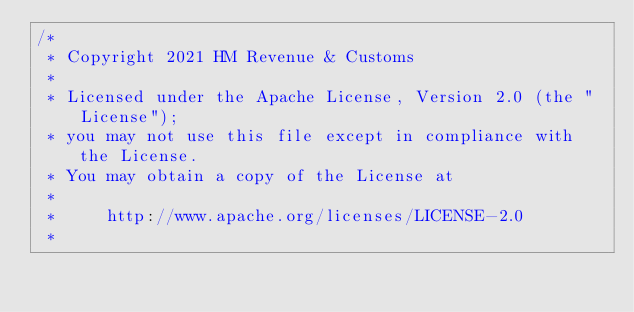Convert code to text. <code><loc_0><loc_0><loc_500><loc_500><_Scala_>/*
 * Copyright 2021 HM Revenue & Customs
 *
 * Licensed under the Apache License, Version 2.0 (the "License");
 * you may not use this file except in compliance with the License.
 * You may obtain a copy of the License at
 *
 *     http://www.apache.org/licenses/LICENSE-2.0
 *</code> 